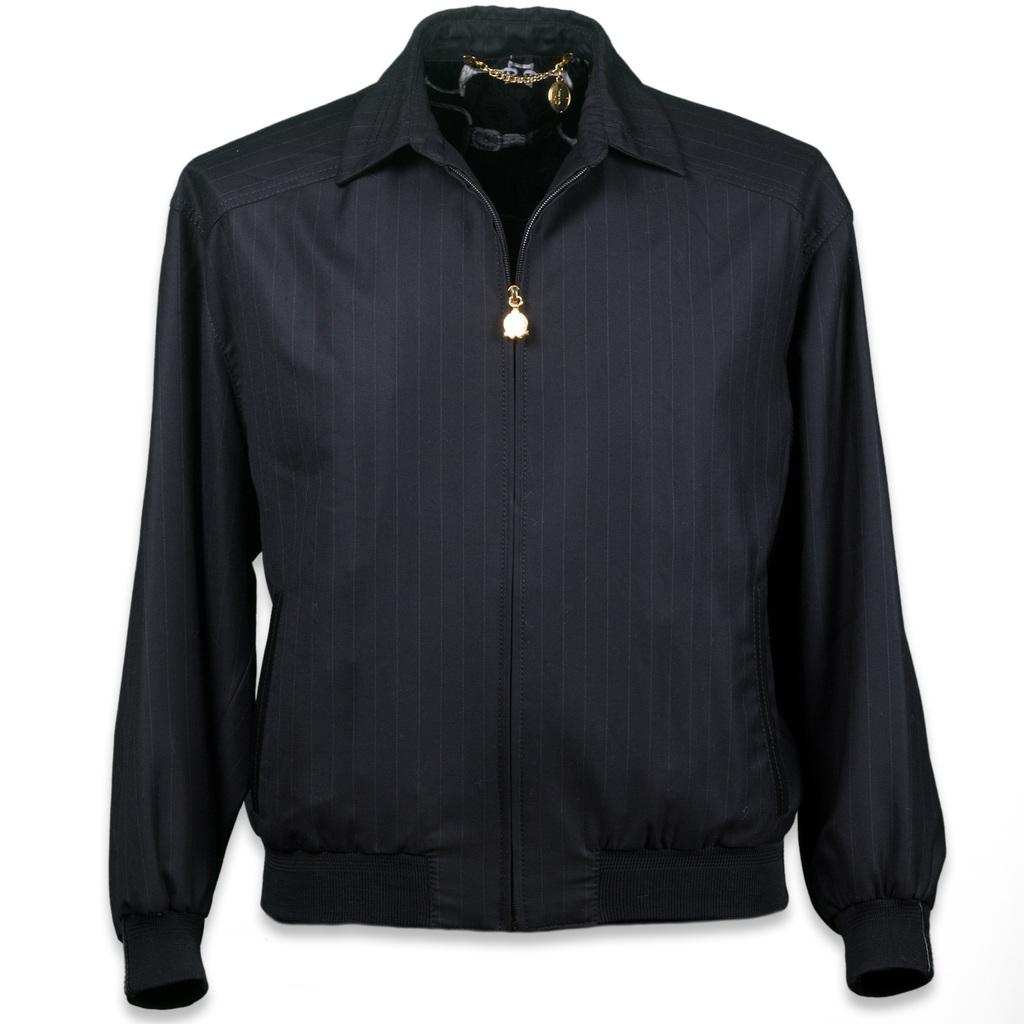What type of clothing item is visible in the image? There is a black jacket in the image. What accessory is present in the image? There is a golden chain in the image. What color is the background of the image? The background of the image is white. What type of scene is depicted in the image? There is no scene depicted in the image; it only features a black jacket and a golden chain against a white background. How many trucks are visible in the image? There are no trucks present in the image. 